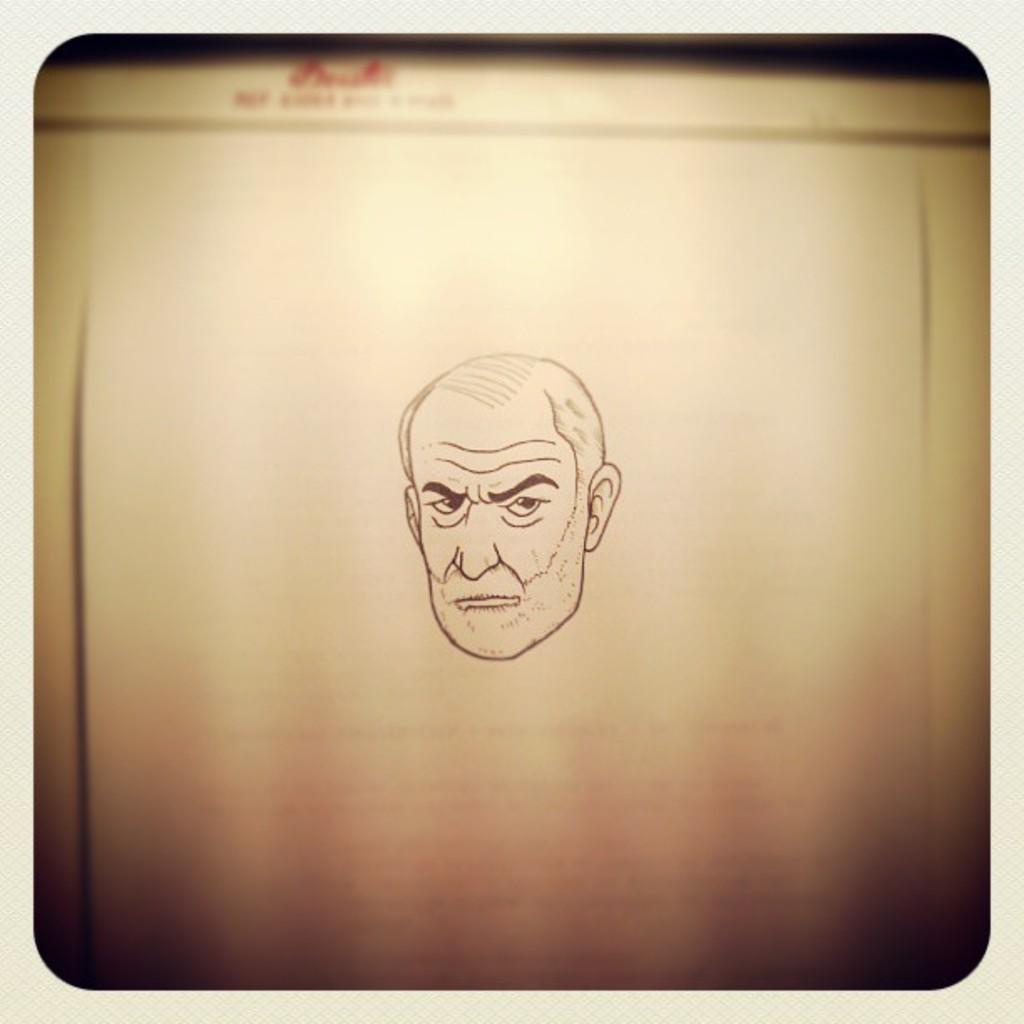What type of image is being described? The image is an edited picture. What can be seen in the edited picture? There is a sketch of a person in the image. Where is the text located in the image? The text is at the top of the image. What type of comfort can be seen in the image? There is no comfort depicted in the image; it features a sketch of a person and text. What type of breakfast is being served in the image? There is no breakfast present in the image; it is an edited picture with a sketch of a person and text. 